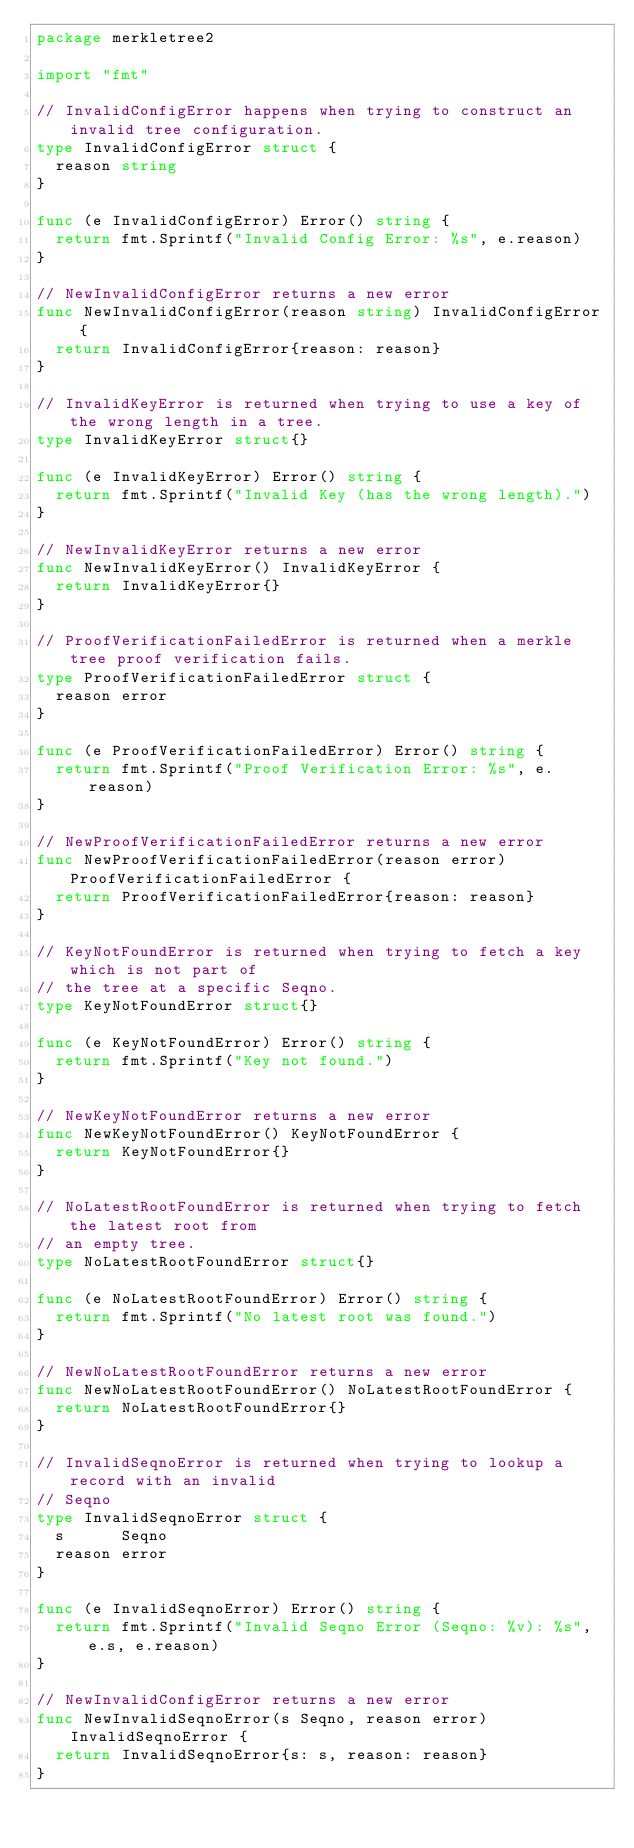<code> <loc_0><loc_0><loc_500><loc_500><_Go_>package merkletree2

import "fmt"

// InvalidConfigError happens when trying to construct an invalid tree configuration.
type InvalidConfigError struct {
	reason string
}

func (e InvalidConfigError) Error() string {
	return fmt.Sprintf("Invalid Config Error: %s", e.reason)
}

// NewInvalidConfigError returns a new error
func NewInvalidConfigError(reason string) InvalidConfigError {
	return InvalidConfigError{reason: reason}
}

// InvalidKeyError is returned when trying to use a key of the wrong length in a tree.
type InvalidKeyError struct{}

func (e InvalidKeyError) Error() string {
	return fmt.Sprintf("Invalid Key (has the wrong length).")
}

// NewInvalidKeyError returns a new error
func NewInvalidKeyError() InvalidKeyError {
	return InvalidKeyError{}
}

// ProofVerificationFailedError is returned when a merkle tree proof verification fails.
type ProofVerificationFailedError struct {
	reason error
}

func (e ProofVerificationFailedError) Error() string {
	return fmt.Sprintf("Proof Verification Error: %s", e.reason)
}

// NewProofVerificationFailedError returns a new error
func NewProofVerificationFailedError(reason error) ProofVerificationFailedError {
	return ProofVerificationFailedError{reason: reason}
}

// KeyNotFoundError is returned when trying to fetch a key which is not part of
// the tree at a specific Seqno.
type KeyNotFoundError struct{}

func (e KeyNotFoundError) Error() string {
	return fmt.Sprintf("Key not found.")
}

// NewKeyNotFoundError returns a new error
func NewKeyNotFoundError() KeyNotFoundError {
	return KeyNotFoundError{}
}

// NoLatestRootFoundError is returned when trying to fetch the latest root from
// an empty tree.
type NoLatestRootFoundError struct{}

func (e NoLatestRootFoundError) Error() string {
	return fmt.Sprintf("No latest root was found.")
}

// NewNoLatestRootFoundError returns a new error
func NewNoLatestRootFoundError() NoLatestRootFoundError {
	return NoLatestRootFoundError{}
}

// InvalidSeqnoError is returned when trying to lookup a record with an invalid
// Seqno
type InvalidSeqnoError struct {
	s      Seqno
	reason error
}

func (e InvalidSeqnoError) Error() string {
	return fmt.Sprintf("Invalid Seqno Error (Seqno: %v): %s", e.s, e.reason)
}

// NewInvalidConfigError returns a new error
func NewInvalidSeqnoError(s Seqno, reason error) InvalidSeqnoError {
	return InvalidSeqnoError{s: s, reason: reason}
}
</code> 